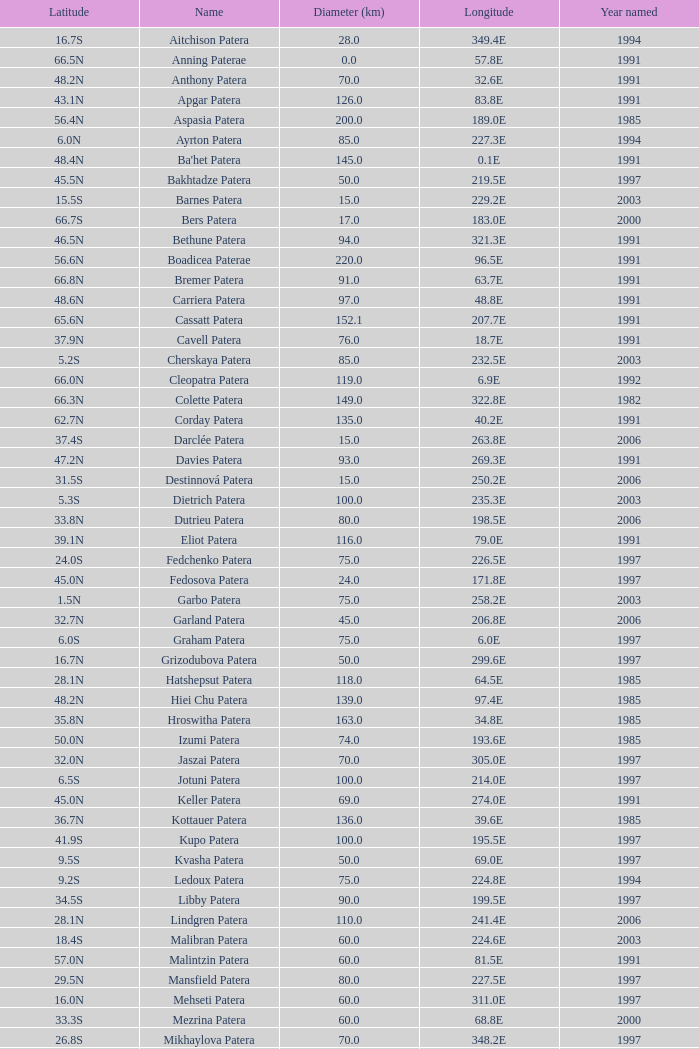What is Longitude, when Name is Raskova Paterae? 222.8E. 